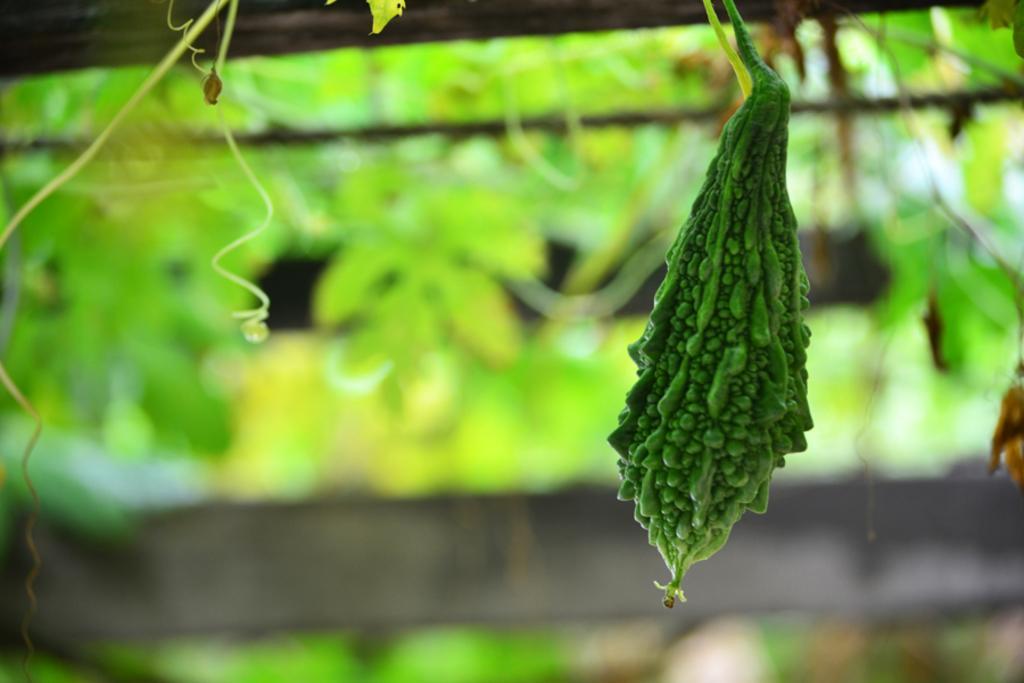Please provide a concise description of this image. In this image we can see a bitter gourd and the background is blurred with some leaves and also the wooden fence. 